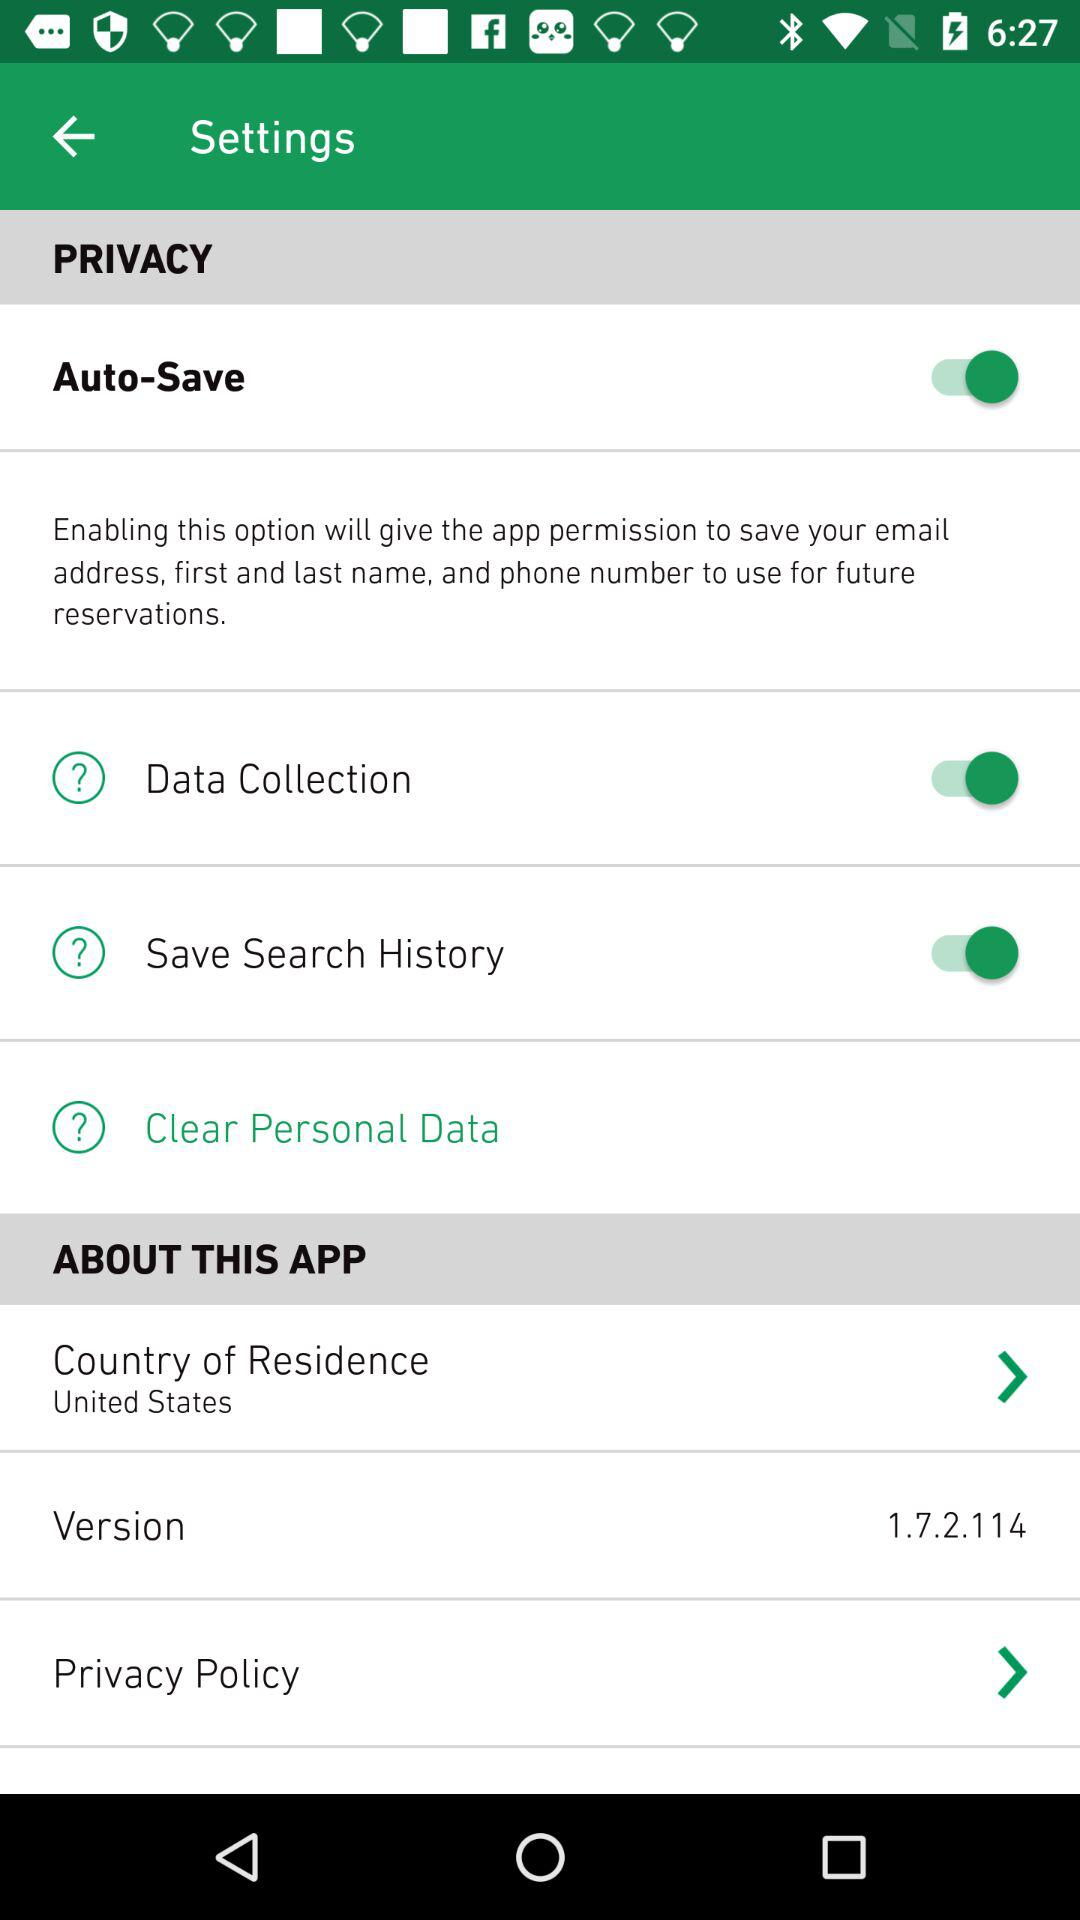What is the status of the "Data Collection"? The status of "Data Collection" is "on". 